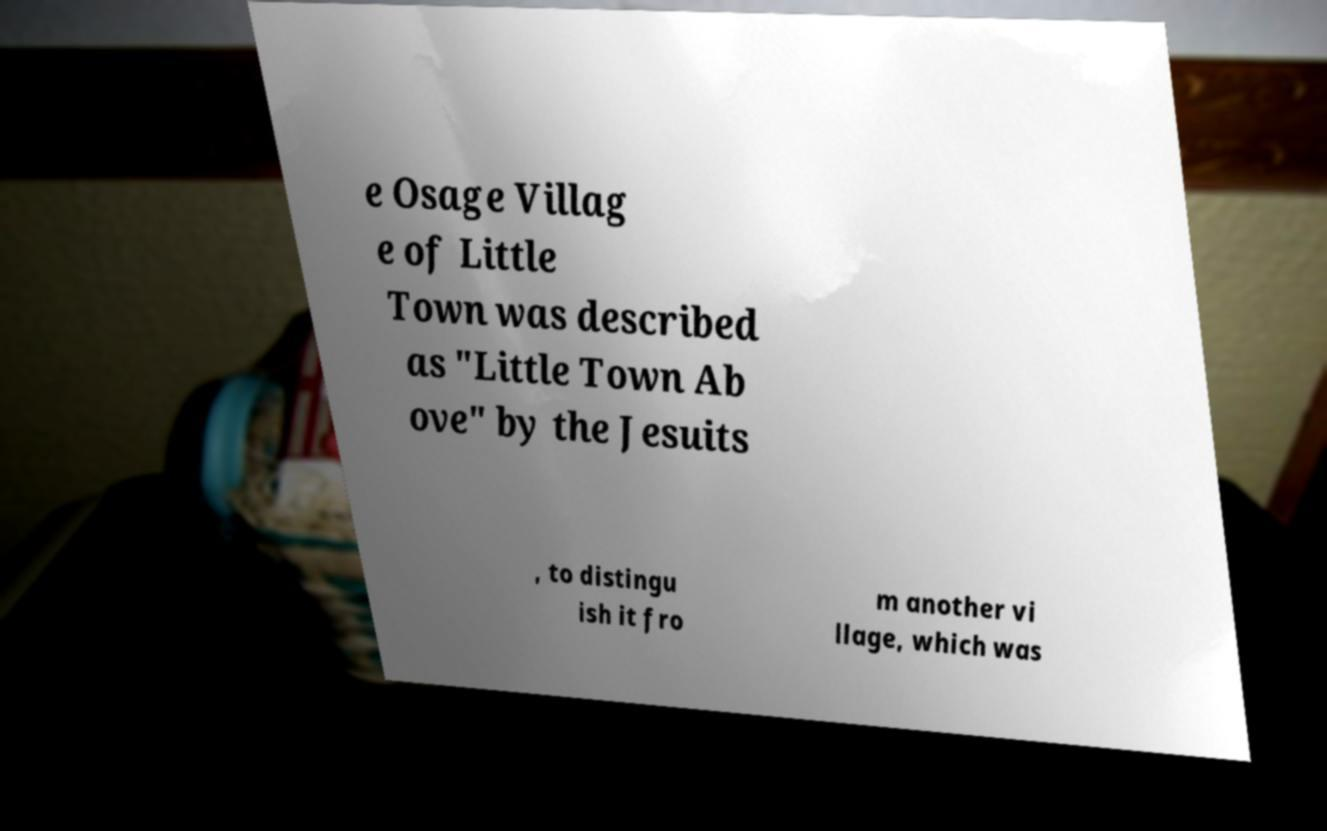Could you assist in decoding the text presented in this image and type it out clearly? e Osage Villag e of Little Town was described as "Little Town Ab ove" by the Jesuits , to distingu ish it fro m another vi llage, which was 